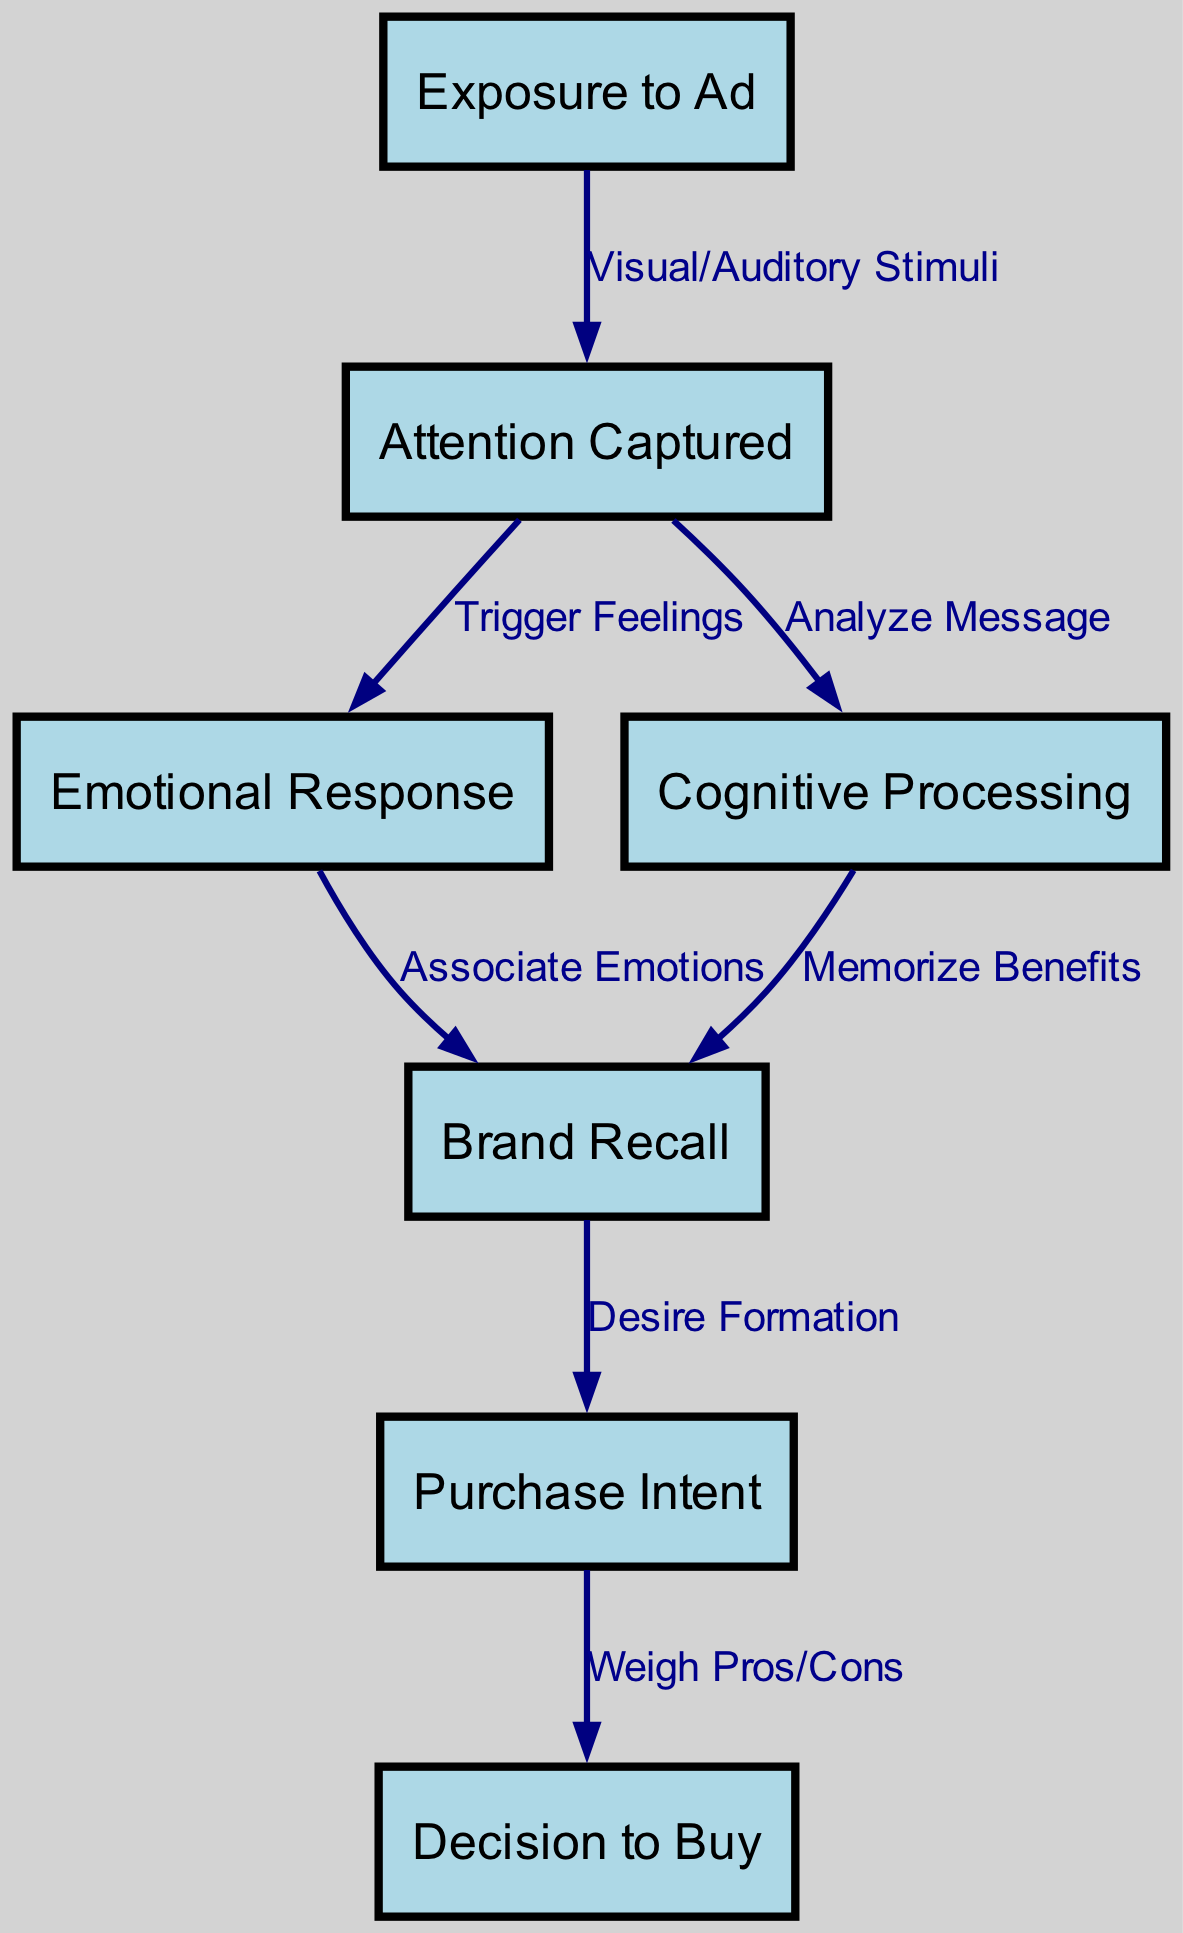What is the first step in the consumer decision-making process? The first step in the flowchart is "Exposure to Ad", which is identified as node 1. This indicates it is the initial action consumers experience when they encounter advertisements.
Answer: Exposure to Ad How many nodes are present in the diagram? By counting the nodes in the data provided, there are seven distinct nodes. These nodes represent various stages in the psychological decision-making process.
Answer: 7 Which node triggers feelings in consumers? The edge from "Attention Captured" to "Emotional Response" shows that this step is responsible for triggering feelings, making "Attention Captured" node 2 the initiator of the emotional response.
Answer: Attention Captured What is the relationship between 'Cognitive Processing' and 'Brand Recall'? There are two edges leading into "Brand Recall", one from "Emotional Response" and the other from "Cognitive Processing". This indicates that both emotional and cognitive aspects contribute to the ability to remember a brand.
Answer: Emotional Response and Cognitive Processing What leads to the 'Decision to Buy'? The flow leading to "Decision to Buy" starts from "Purchase Intent". This step represents the last thought before consumers make their purchasing decision after weighing pros and cons.
Answer: Purchase Intent What type of stimuli is involved in capturing attention? The edge from "Exposure to Ad" to "Attention Captured" uses the label "Visual/Auditory Stimuli". This indicates that these sensory stimuli are key elements in attracting consumer attention within the decision-making process.
Answer: Visual/Auditory Stimuli Which node is the last in the decision-making process? "Decision to Buy" is the final node in the flowchart, indicating that it is where the consumer concludes their decision-making journey after all prior steps have been completed.
Answer: Decision to Buy What is the main purpose of 'Cognitive Processing'? The edge from "Attention Captured" to "Cognitive Processing" is labeled "Analyze Message", which indicates that the purpose of cognitive processing is to analyze the message received from the advertisement.
Answer: Analyze Message 